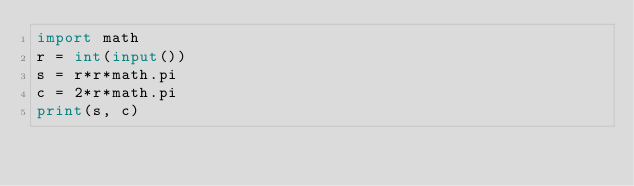<code> <loc_0><loc_0><loc_500><loc_500><_Python_>import math
r = int(input())
s = r*r*math.pi
c = 2*r*math.pi
print(s, c)
</code> 